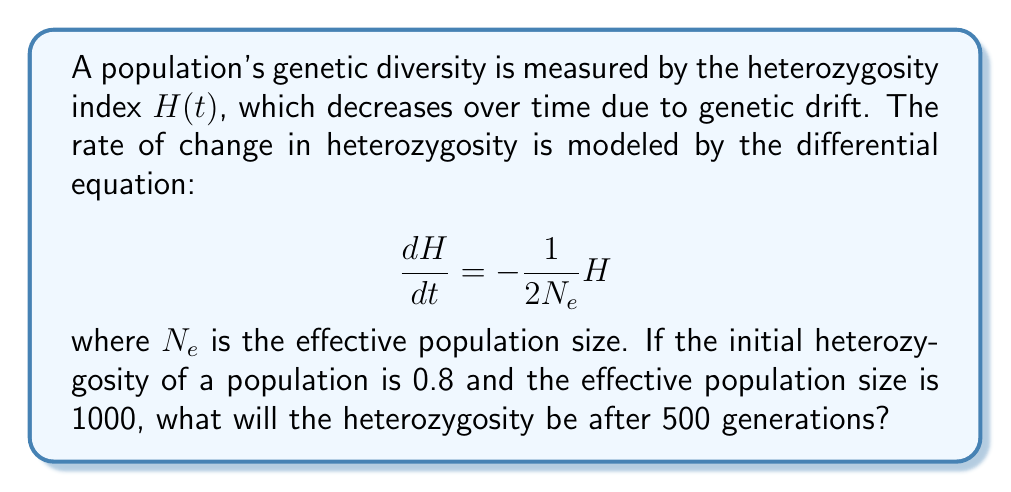What is the answer to this math problem? To solve this first-order differential equation, we follow these steps:

1) The given equation is separable. We can rewrite it as:

   $$\frac{dH}{H} = -\frac{1}{2N_e}dt$$

2) Integrate both sides:

   $$\int \frac{dH}{H} = -\frac{1}{2N_e} \int dt$$

3) This gives us:

   $$\ln|H| = -\frac{1}{2N_e}t + C$$

4) Take the exponential of both sides:

   $$H = e^{-\frac{1}{2N_e}t + C} = Ae^{-\frac{1}{2N_e}t}$$

   where $A = e^C$ is a constant.

5) Use the initial condition: When $t=0$, $H=0.8$. This gives:

   $$0.8 = Ae^{-\frac{1}{2N_e}(0)} = A$$

6) Therefore, the solution is:

   $$H(t) = 0.8e^{-\frac{1}{2N_e}t}$$

7) Now, we can substitute the given values: $N_e = 1000$ and $t = 500$ generations:

   $$H(500) = 0.8e^{-\frac{1}{2(1000)}(500)} = 0.8e^{-0.25} \approx 0.6224$$
Answer: The heterozygosity after 500 generations will be approximately 0.6224. 